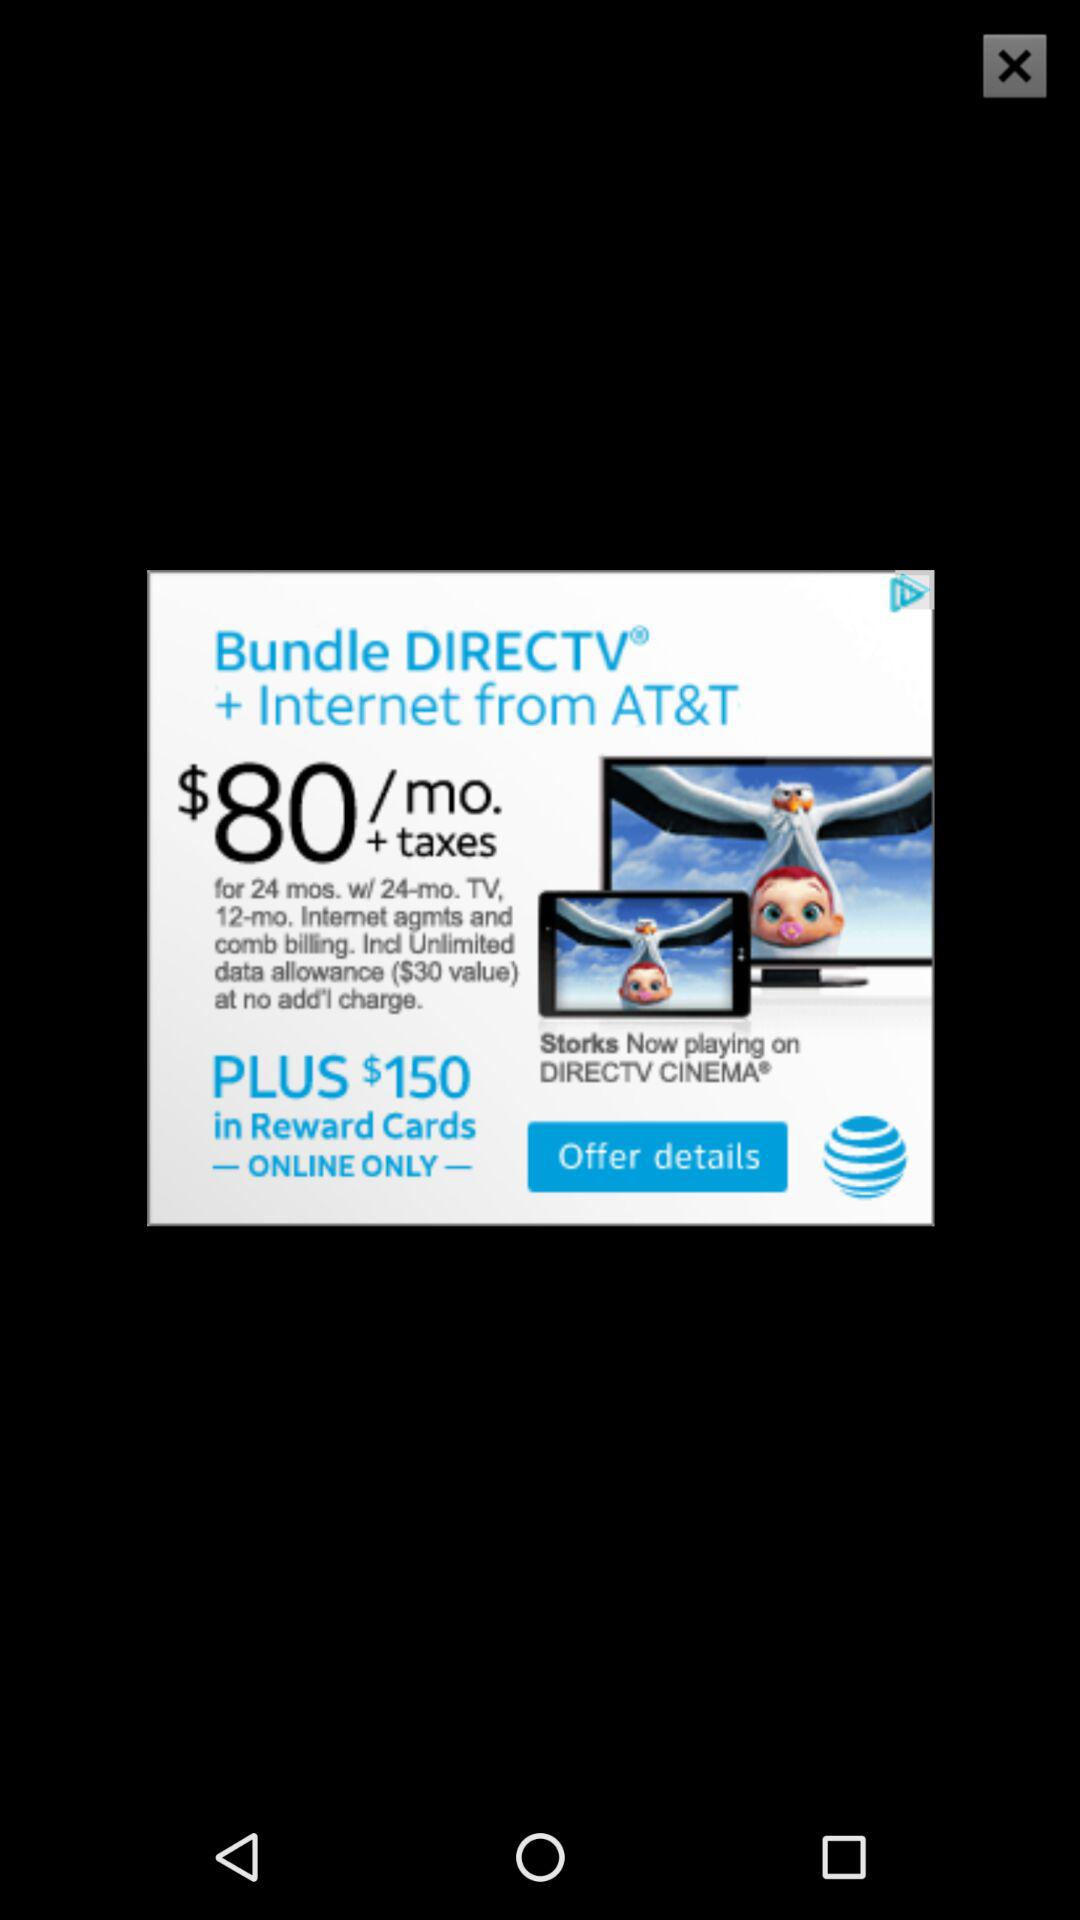How much is the reward card value?
Answer the question using a single word or phrase. $150 